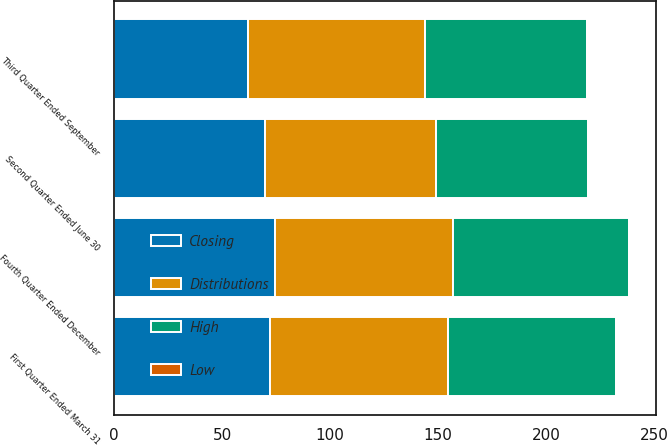Convert chart to OTSL. <chart><loc_0><loc_0><loc_500><loc_500><stacked_bar_chart><ecel><fcel>Fourth Quarter Ended December<fcel>Third Quarter Ended September<fcel>Second Quarter Ended June 30<fcel>First Quarter Ended March 31<nl><fcel>Distributions<fcel>82.39<fcel>81.98<fcel>79.23<fcel>82.53<nl><fcel>Closing<fcel>74.38<fcel>61.9<fcel>69.94<fcel>72.06<nl><fcel>High<fcel>81.59<fcel>75.12<fcel>70.17<fcel>77.86<nl><fcel>Low<fcel>0.55<fcel>0.55<fcel>0.55<fcel>0.55<nl></chart> 